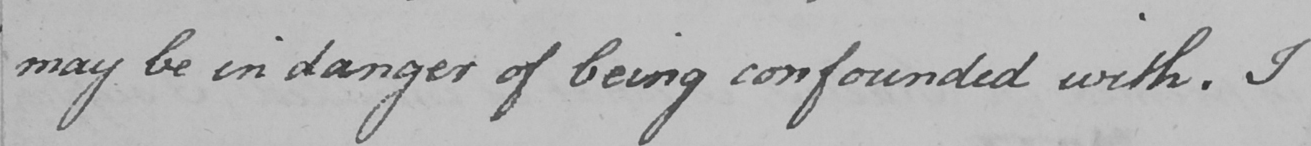Can you tell me what this handwritten text says? may be in danger of being confounded with . I 